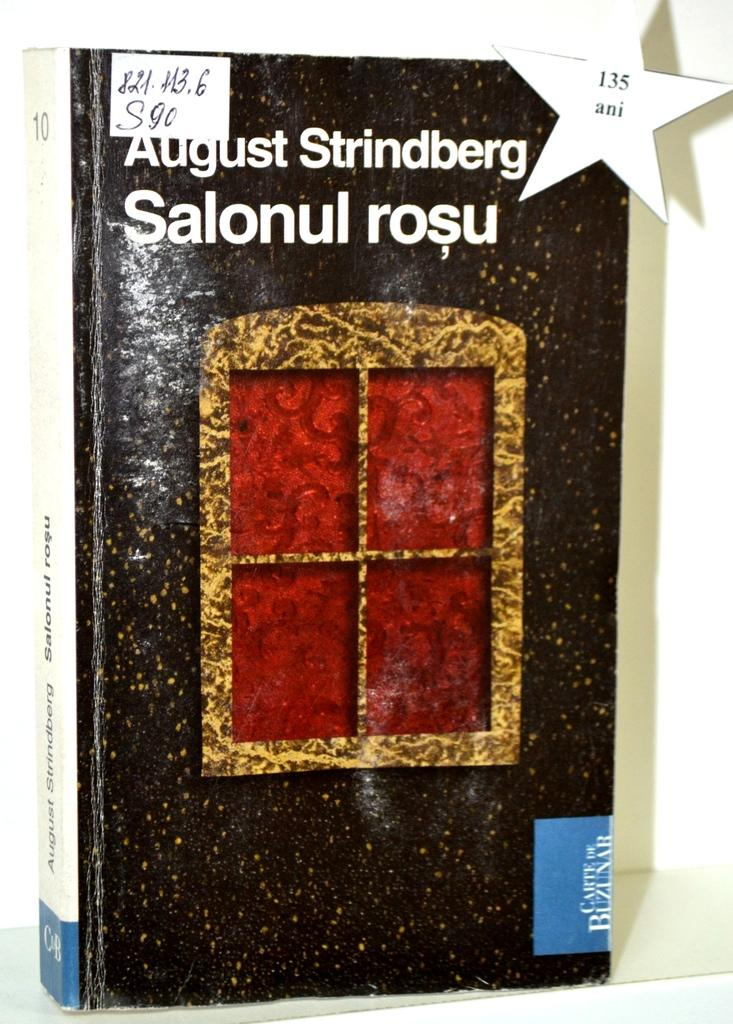What is the main object in the image? There is a book in the image. What information can be found on the book? The book has the name "August Strainberg Salon or Roseau" on it. What type of artwork is featured on the book? There is a window-like painting on the book. What type of produce is being harvested in the image? There is no produce or harvesting depicted in the image; it features a book with a window-like painting. What type of rock formation can be seen in the image? There are no rock formations present in the image; it features a book with a window-like painting. 